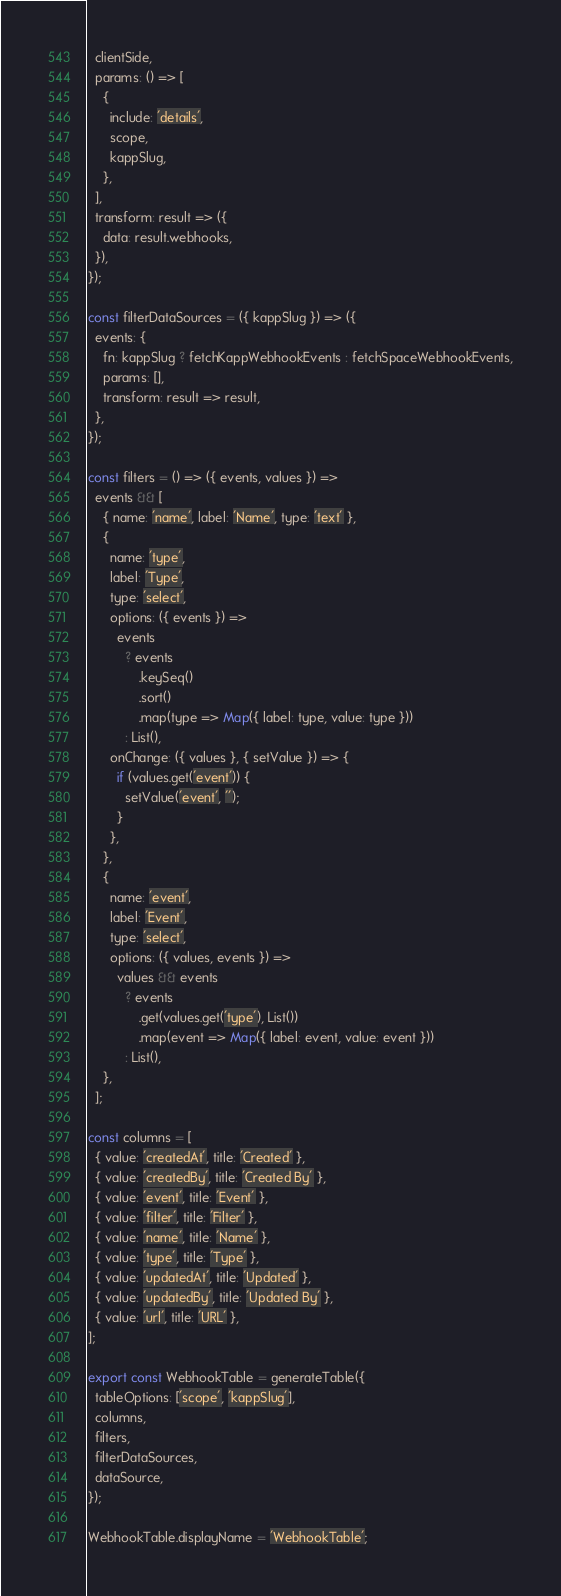Convert code to text. <code><loc_0><loc_0><loc_500><loc_500><_JavaScript_>  clientSide,
  params: () => [
    {
      include: 'details',
      scope,
      kappSlug,
    },
  ],
  transform: result => ({
    data: result.webhooks,
  }),
});

const filterDataSources = ({ kappSlug }) => ({
  events: {
    fn: kappSlug ? fetchKappWebhookEvents : fetchSpaceWebhookEvents,
    params: [],
    transform: result => result,
  },
});

const filters = () => ({ events, values }) =>
  events && [
    { name: 'name', label: 'Name', type: 'text' },
    {
      name: 'type',
      label: 'Type',
      type: 'select',
      options: ({ events }) =>
        events
          ? events
              .keySeq()
              .sort()
              .map(type => Map({ label: type, value: type }))
          : List(),
      onChange: ({ values }, { setValue }) => {
        if (values.get('event')) {
          setValue('event', '');
        }
      },
    },
    {
      name: 'event',
      label: 'Event',
      type: 'select',
      options: ({ values, events }) =>
        values && events
          ? events
              .get(values.get('type'), List())
              .map(event => Map({ label: event, value: event }))
          : List(),
    },
  ];

const columns = [
  { value: 'createdAt', title: 'Created' },
  { value: 'createdBy', title: 'Created By' },
  { value: 'event', title: 'Event' },
  { value: 'filter', title: 'Filter' },
  { value: 'name', title: 'Name' },
  { value: 'type', title: 'Type' },
  { value: 'updatedAt', title: 'Updated' },
  { value: 'updatedBy', title: 'Updated By' },
  { value: 'url', title: 'URL' },
];

export const WebhookTable = generateTable({
  tableOptions: ['scope', 'kappSlug'],
  columns,
  filters,
  filterDataSources,
  dataSource,
});

WebhookTable.displayName = 'WebhookTable';
</code> 